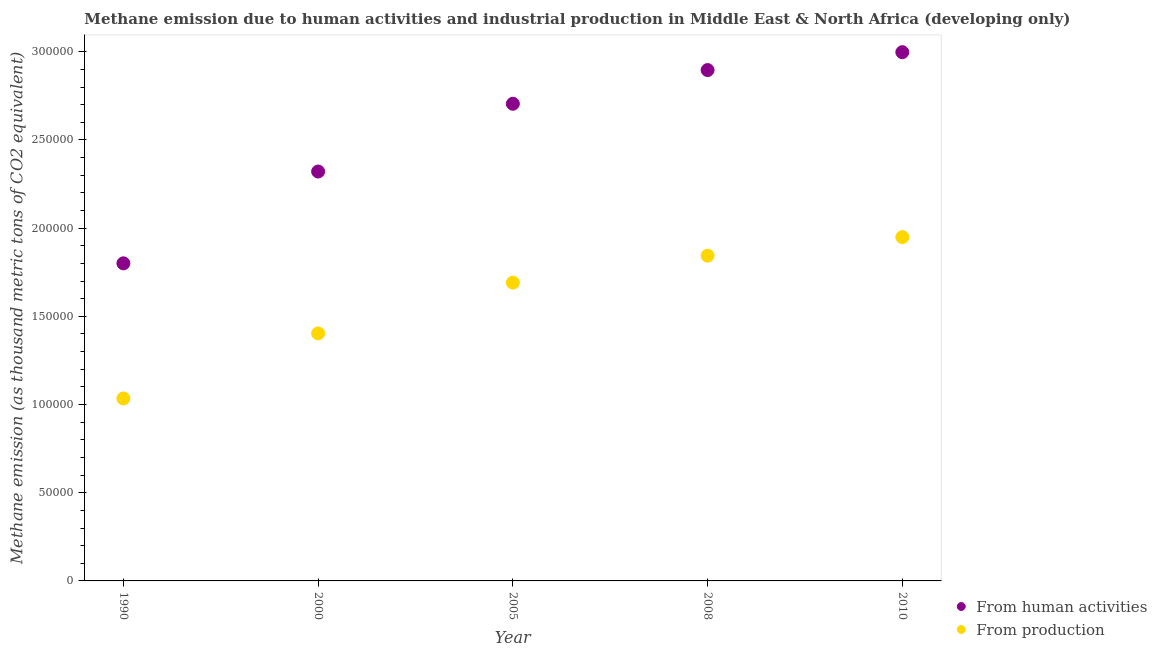How many different coloured dotlines are there?
Your answer should be compact. 2. Is the number of dotlines equal to the number of legend labels?
Keep it short and to the point. Yes. What is the amount of emissions generated from industries in 2000?
Give a very brief answer. 1.40e+05. Across all years, what is the maximum amount of emissions from human activities?
Offer a very short reply. 3.00e+05. Across all years, what is the minimum amount of emissions from human activities?
Ensure brevity in your answer.  1.80e+05. In which year was the amount of emissions generated from industries maximum?
Offer a very short reply. 2010. What is the total amount of emissions generated from industries in the graph?
Make the answer very short. 7.92e+05. What is the difference between the amount of emissions generated from industries in 2005 and that in 2010?
Offer a terse response. -2.58e+04. What is the difference between the amount of emissions from human activities in 2000 and the amount of emissions generated from industries in 2005?
Ensure brevity in your answer.  6.30e+04. What is the average amount of emissions generated from industries per year?
Give a very brief answer. 1.58e+05. In the year 2010, what is the difference between the amount of emissions generated from industries and amount of emissions from human activities?
Give a very brief answer. -1.05e+05. What is the ratio of the amount of emissions from human activities in 2005 to that in 2008?
Offer a terse response. 0.93. Is the amount of emissions generated from industries in 2000 less than that in 2005?
Your answer should be very brief. Yes. What is the difference between the highest and the second highest amount of emissions from human activities?
Make the answer very short. 1.01e+04. What is the difference between the highest and the lowest amount of emissions from human activities?
Your answer should be compact. 1.20e+05. Is the sum of the amount of emissions from human activities in 2000 and 2010 greater than the maximum amount of emissions generated from industries across all years?
Give a very brief answer. Yes. Does the amount of emissions generated from industries monotonically increase over the years?
Provide a succinct answer. Yes. How many dotlines are there?
Keep it short and to the point. 2. Are the values on the major ticks of Y-axis written in scientific E-notation?
Offer a terse response. No. Does the graph contain any zero values?
Keep it short and to the point. No. Does the graph contain grids?
Offer a terse response. No. Where does the legend appear in the graph?
Your answer should be very brief. Bottom right. How many legend labels are there?
Your response must be concise. 2. How are the legend labels stacked?
Make the answer very short. Vertical. What is the title of the graph?
Your response must be concise. Methane emission due to human activities and industrial production in Middle East & North Africa (developing only). What is the label or title of the Y-axis?
Ensure brevity in your answer.  Methane emission (as thousand metric tons of CO2 equivalent). What is the Methane emission (as thousand metric tons of CO2 equivalent) of From human activities in 1990?
Your answer should be compact. 1.80e+05. What is the Methane emission (as thousand metric tons of CO2 equivalent) of From production in 1990?
Provide a short and direct response. 1.03e+05. What is the Methane emission (as thousand metric tons of CO2 equivalent) in From human activities in 2000?
Offer a terse response. 2.32e+05. What is the Methane emission (as thousand metric tons of CO2 equivalent) in From production in 2000?
Provide a short and direct response. 1.40e+05. What is the Methane emission (as thousand metric tons of CO2 equivalent) of From human activities in 2005?
Provide a short and direct response. 2.71e+05. What is the Methane emission (as thousand metric tons of CO2 equivalent) of From production in 2005?
Offer a terse response. 1.69e+05. What is the Methane emission (as thousand metric tons of CO2 equivalent) of From human activities in 2008?
Ensure brevity in your answer.  2.90e+05. What is the Methane emission (as thousand metric tons of CO2 equivalent) of From production in 2008?
Your answer should be very brief. 1.84e+05. What is the Methane emission (as thousand metric tons of CO2 equivalent) of From human activities in 2010?
Provide a short and direct response. 3.00e+05. What is the Methane emission (as thousand metric tons of CO2 equivalent) in From production in 2010?
Ensure brevity in your answer.  1.95e+05. Across all years, what is the maximum Methane emission (as thousand metric tons of CO2 equivalent) of From human activities?
Offer a terse response. 3.00e+05. Across all years, what is the maximum Methane emission (as thousand metric tons of CO2 equivalent) of From production?
Provide a short and direct response. 1.95e+05. Across all years, what is the minimum Methane emission (as thousand metric tons of CO2 equivalent) in From human activities?
Make the answer very short. 1.80e+05. Across all years, what is the minimum Methane emission (as thousand metric tons of CO2 equivalent) of From production?
Provide a succinct answer. 1.03e+05. What is the total Methane emission (as thousand metric tons of CO2 equivalent) in From human activities in the graph?
Ensure brevity in your answer.  1.27e+06. What is the total Methane emission (as thousand metric tons of CO2 equivalent) of From production in the graph?
Keep it short and to the point. 7.92e+05. What is the difference between the Methane emission (as thousand metric tons of CO2 equivalent) of From human activities in 1990 and that in 2000?
Make the answer very short. -5.20e+04. What is the difference between the Methane emission (as thousand metric tons of CO2 equivalent) of From production in 1990 and that in 2000?
Ensure brevity in your answer.  -3.69e+04. What is the difference between the Methane emission (as thousand metric tons of CO2 equivalent) in From human activities in 1990 and that in 2005?
Your response must be concise. -9.05e+04. What is the difference between the Methane emission (as thousand metric tons of CO2 equivalent) in From production in 1990 and that in 2005?
Offer a very short reply. -6.57e+04. What is the difference between the Methane emission (as thousand metric tons of CO2 equivalent) in From human activities in 1990 and that in 2008?
Ensure brevity in your answer.  -1.10e+05. What is the difference between the Methane emission (as thousand metric tons of CO2 equivalent) in From production in 1990 and that in 2008?
Keep it short and to the point. -8.10e+04. What is the difference between the Methane emission (as thousand metric tons of CO2 equivalent) of From human activities in 1990 and that in 2010?
Keep it short and to the point. -1.20e+05. What is the difference between the Methane emission (as thousand metric tons of CO2 equivalent) of From production in 1990 and that in 2010?
Provide a short and direct response. -9.15e+04. What is the difference between the Methane emission (as thousand metric tons of CO2 equivalent) in From human activities in 2000 and that in 2005?
Your response must be concise. -3.84e+04. What is the difference between the Methane emission (as thousand metric tons of CO2 equivalent) in From production in 2000 and that in 2005?
Give a very brief answer. -2.88e+04. What is the difference between the Methane emission (as thousand metric tons of CO2 equivalent) of From human activities in 2000 and that in 2008?
Offer a very short reply. -5.75e+04. What is the difference between the Methane emission (as thousand metric tons of CO2 equivalent) of From production in 2000 and that in 2008?
Offer a terse response. -4.41e+04. What is the difference between the Methane emission (as thousand metric tons of CO2 equivalent) in From human activities in 2000 and that in 2010?
Give a very brief answer. -6.76e+04. What is the difference between the Methane emission (as thousand metric tons of CO2 equivalent) in From production in 2000 and that in 2010?
Your response must be concise. -5.46e+04. What is the difference between the Methane emission (as thousand metric tons of CO2 equivalent) in From human activities in 2005 and that in 2008?
Provide a short and direct response. -1.91e+04. What is the difference between the Methane emission (as thousand metric tons of CO2 equivalent) of From production in 2005 and that in 2008?
Make the answer very short. -1.53e+04. What is the difference between the Methane emission (as thousand metric tons of CO2 equivalent) in From human activities in 2005 and that in 2010?
Provide a succinct answer. -2.92e+04. What is the difference between the Methane emission (as thousand metric tons of CO2 equivalent) of From production in 2005 and that in 2010?
Make the answer very short. -2.58e+04. What is the difference between the Methane emission (as thousand metric tons of CO2 equivalent) of From human activities in 2008 and that in 2010?
Give a very brief answer. -1.01e+04. What is the difference between the Methane emission (as thousand metric tons of CO2 equivalent) in From production in 2008 and that in 2010?
Offer a terse response. -1.05e+04. What is the difference between the Methane emission (as thousand metric tons of CO2 equivalent) of From human activities in 1990 and the Methane emission (as thousand metric tons of CO2 equivalent) of From production in 2000?
Your answer should be compact. 3.97e+04. What is the difference between the Methane emission (as thousand metric tons of CO2 equivalent) in From human activities in 1990 and the Methane emission (as thousand metric tons of CO2 equivalent) in From production in 2005?
Give a very brief answer. 1.09e+04. What is the difference between the Methane emission (as thousand metric tons of CO2 equivalent) of From human activities in 1990 and the Methane emission (as thousand metric tons of CO2 equivalent) of From production in 2008?
Offer a very short reply. -4343.5. What is the difference between the Methane emission (as thousand metric tons of CO2 equivalent) of From human activities in 1990 and the Methane emission (as thousand metric tons of CO2 equivalent) of From production in 2010?
Provide a short and direct response. -1.49e+04. What is the difference between the Methane emission (as thousand metric tons of CO2 equivalent) of From human activities in 2000 and the Methane emission (as thousand metric tons of CO2 equivalent) of From production in 2005?
Your answer should be compact. 6.30e+04. What is the difference between the Methane emission (as thousand metric tons of CO2 equivalent) of From human activities in 2000 and the Methane emission (as thousand metric tons of CO2 equivalent) of From production in 2008?
Ensure brevity in your answer.  4.77e+04. What is the difference between the Methane emission (as thousand metric tons of CO2 equivalent) of From human activities in 2000 and the Methane emission (as thousand metric tons of CO2 equivalent) of From production in 2010?
Provide a short and direct response. 3.72e+04. What is the difference between the Methane emission (as thousand metric tons of CO2 equivalent) of From human activities in 2005 and the Methane emission (as thousand metric tons of CO2 equivalent) of From production in 2008?
Your response must be concise. 8.61e+04. What is the difference between the Methane emission (as thousand metric tons of CO2 equivalent) in From human activities in 2005 and the Methane emission (as thousand metric tons of CO2 equivalent) in From production in 2010?
Your answer should be compact. 7.56e+04. What is the difference between the Methane emission (as thousand metric tons of CO2 equivalent) in From human activities in 2008 and the Methane emission (as thousand metric tons of CO2 equivalent) in From production in 2010?
Your answer should be compact. 9.47e+04. What is the average Methane emission (as thousand metric tons of CO2 equivalent) of From human activities per year?
Your response must be concise. 2.54e+05. What is the average Methane emission (as thousand metric tons of CO2 equivalent) of From production per year?
Your answer should be compact. 1.58e+05. In the year 1990, what is the difference between the Methane emission (as thousand metric tons of CO2 equivalent) in From human activities and Methane emission (as thousand metric tons of CO2 equivalent) in From production?
Your response must be concise. 7.66e+04. In the year 2000, what is the difference between the Methane emission (as thousand metric tons of CO2 equivalent) in From human activities and Methane emission (as thousand metric tons of CO2 equivalent) in From production?
Provide a short and direct response. 9.18e+04. In the year 2005, what is the difference between the Methane emission (as thousand metric tons of CO2 equivalent) of From human activities and Methane emission (as thousand metric tons of CO2 equivalent) of From production?
Provide a short and direct response. 1.01e+05. In the year 2008, what is the difference between the Methane emission (as thousand metric tons of CO2 equivalent) in From human activities and Methane emission (as thousand metric tons of CO2 equivalent) in From production?
Offer a very short reply. 1.05e+05. In the year 2010, what is the difference between the Methane emission (as thousand metric tons of CO2 equivalent) of From human activities and Methane emission (as thousand metric tons of CO2 equivalent) of From production?
Provide a succinct answer. 1.05e+05. What is the ratio of the Methane emission (as thousand metric tons of CO2 equivalent) of From human activities in 1990 to that in 2000?
Make the answer very short. 0.78. What is the ratio of the Methane emission (as thousand metric tons of CO2 equivalent) of From production in 1990 to that in 2000?
Your answer should be very brief. 0.74. What is the ratio of the Methane emission (as thousand metric tons of CO2 equivalent) of From human activities in 1990 to that in 2005?
Offer a terse response. 0.67. What is the ratio of the Methane emission (as thousand metric tons of CO2 equivalent) of From production in 1990 to that in 2005?
Provide a short and direct response. 0.61. What is the ratio of the Methane emission (as thousand metric tons of CO2 equivalent) in From human activities in 1990 to that in 2008?
Provide a short and direct response. 0.62. What is the ratio of the Methane emission (as thousand metric tons of CO2 equivalent) in From production in 1990 to that in 2008?
Provide a short and direct response. 0.56. What is the ratio of the Methane emission (as thousand metric tons of CO2 equivalent) of From human activities in 1990 to that in 2010?
Ensure brevity in your answer.  0.6. What is the ratio of the Methane emission (as thousand metric tons of CO2 equivalent) of From production in 1990 to that in 2010?
Keep it short and to the point. 0.53. What is the ratio of the Methane emission (as thousand metric tons of CO2 equivalent) in From human activities in 2000 to that in 2005?
Provide a succinct answer. 0.86. What is the ratio of the Methane emission (as thousand metric tons of CO2 equivalent) of From production in 2000 to that in 2005?
Your response must be concise. 0.83. What is the ratio of the Methane emission (as thousand metric tons of CO2 equivalent) in From human activities in 2000 to that in 2008?
Provide a short and direct response. 0.8. What is the ratio of the Methane emission (as thousand metric tons of CO2 equivalent) in From production in 2000 to that in 2008?
Keep it short and to the point. 0.76. What is the ratio of the Methane emission (as thousand metric tons of CO2 equivalent) in From human activities in 2000 to that in 2010?
Your answer should be very brief. 0.77. What is the ratio of the Methane emission (as thousand metric tons of CO2 equivalent) of From production in 2000 to that in 2010?
Provide a succinct answer. 0.72. What is the ratio of the Methane emission (as thousand metric tons of CO2 equivalent) in From human activities in 2005 to that in 2008?
Your answer should be very brief. 0.93. What is the ratio of the Methane emission (as thousand metric tons of CO2 equivalent) in From production in 2005 to that in 2008?
Give a very brief answer. 0.92. What is the ratio of the Methane emission (as thousand metric tons of CO2 equivalent) in From human activities in 2005 to that in 2010?
Your answer should be very brief. 0.9. What is the ratio of the Methane emission (as thousand metric tons of CO2 equivalent) in From production in 2005 to that in 2010?
Provide a succinct answer. 0.87. What is the ratio of the Methane emission (as thousand metric tons of CO2 equivalent) in From human activities in 2008 to that in 2010?
Provide a short and direct response. 0.97. What is the ratio of the Methane emission (as thousand metric tons of CO2 equivalent) in From production in 2008 to that in 2010?
Make the answer very short. 0.95. What is the difference between the highest and the second highest Methane emission (as thousand metric tons of CO2 equivalent) in From human activities?
Provide a short and direct response. 1.01e+04. What is the difference between the highest and the second highest Methane emission (as thousand metric tons of CO2 equivalent) in From production?
Your answer should be compact. 1.05e+04. What is the difference between the highest and the lowest Methane emission (as thousand metric tons of CO2 equivalent) of From human activities?
Give a very brief answer. 1.20e+05. What is the difference between the highest and the lowest Methane emission (as thousand metric tons of CO2 equivalent) of From production?
Give a very brief answer. 9.15e+04. 